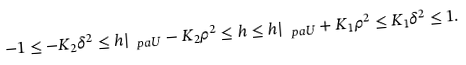Convert formula to latex. <formula><loc_0><loc_0><loc_500><loc_500>- 1 \leq - K _ { 2 } \delta ^ { 2 } \leq h | _ { \ p a U } - K _ { 2 } \rho ^ { 2 } \leq h \leq h | _ { \ p a U } + K _ { 1 } \rho ^ { 2 } \leq K _ { 1 } \delta ^ { 2 } \leq 1 .</formula> 